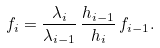<formula> <loc_0><loc_0><loc_500><loc_500>f _ { i } = \frac { \lambda _ { i } } { \lambda _ { i - 1 } } \, \frac { h _ { i - 1 } } { h _ { i } } \, f _ { i - 1 } .</formula> 